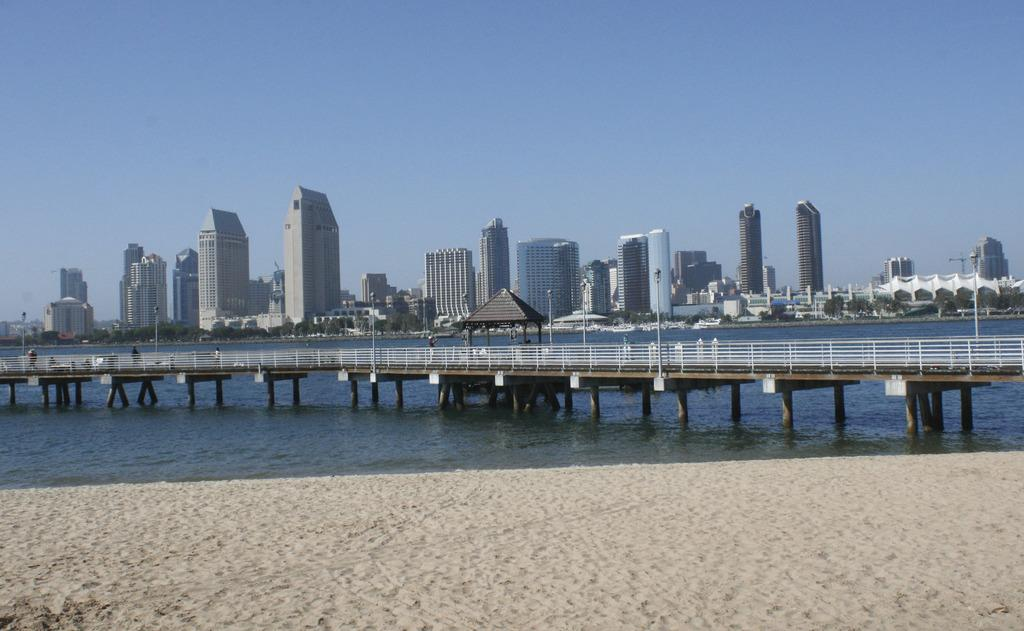What is the main structure in the image? There is a bridge in the image. What is the bridge positioned over? The bridge is over water. What type of terrain is in front of the water? There is sand in front of the water. What can be seen in the distance behind the bridge? There are buildings in the background of the image. How many bananas can be seen hanging from the bridge in the image? There are no bananas present in the image; the bridge is over water, not bananas. What type of zipper is visible on the buildings in the background? There is no zipper visible on the buildings in the background; the image only shows the buildings' general appearance. 